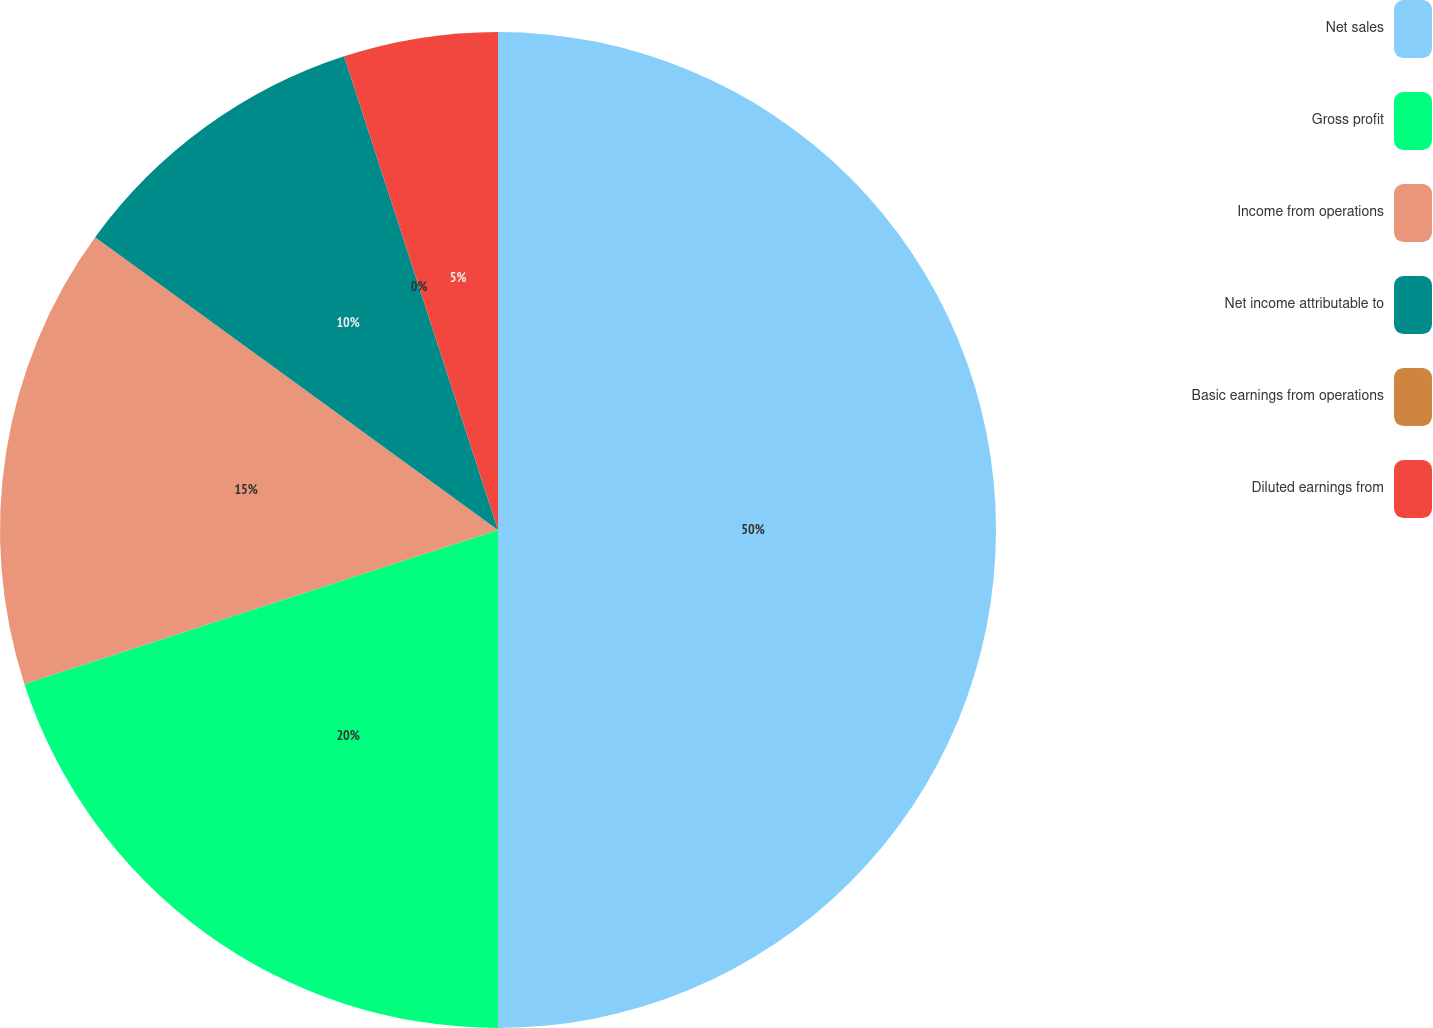<chart> <loc_0><loc_0><loc_500><loc_500><pie_chart><fcel>Net sales<fcel>Gross profit<fcel>Income from operations<fcel>Net income attributable to<fcel>Basic earnings from operations<fcel>Diluted earnings from<nl><fcel>50.0%<fcel>20.0%<fcel>15.0%<fcel>10.0%<fcel>0.0%<fcel>5.0%<nl></chart> 